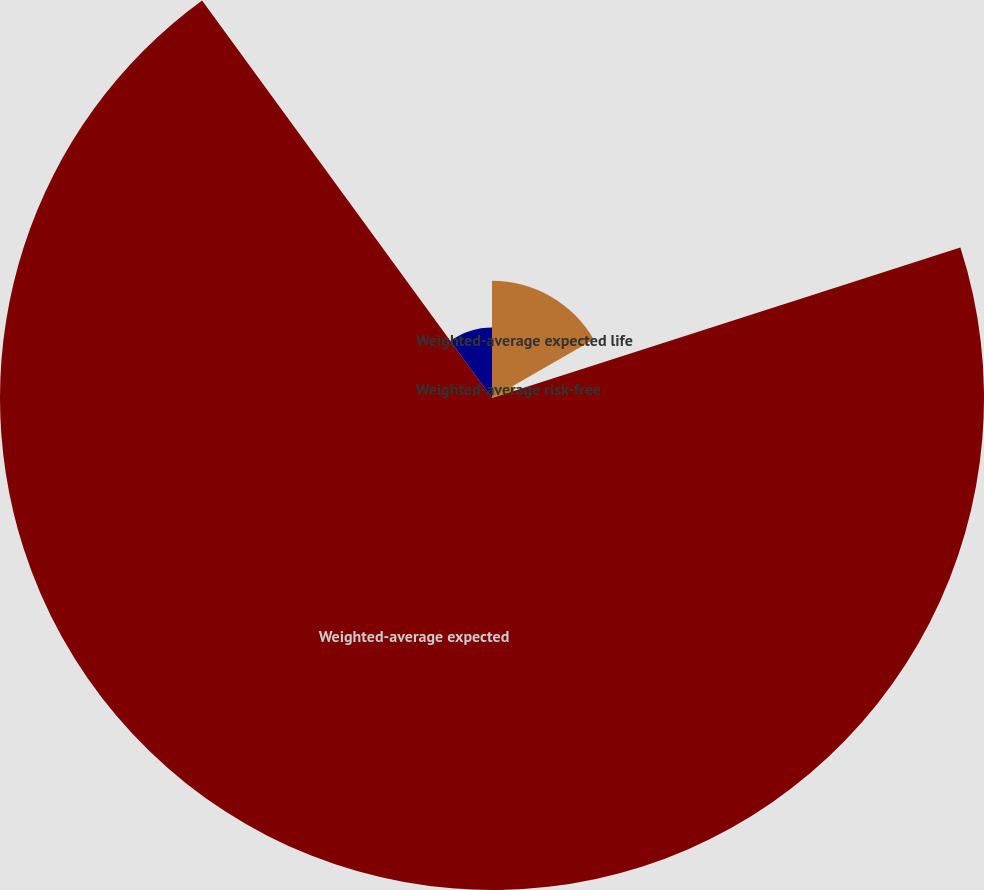Convert chart to OTSL. <chart><loc_0><loc_0><loc_500><loc_500><pie_chart><fcel>Weighted-average expected life<fcel>Weighted-average risk-free<fcel>Weighted-average expected<fcel>Weighted-average fair value<nl><fcel>16.68%<fcel>3.37%<fcel>69.92%<fcel>10.03%<nl></chart> 